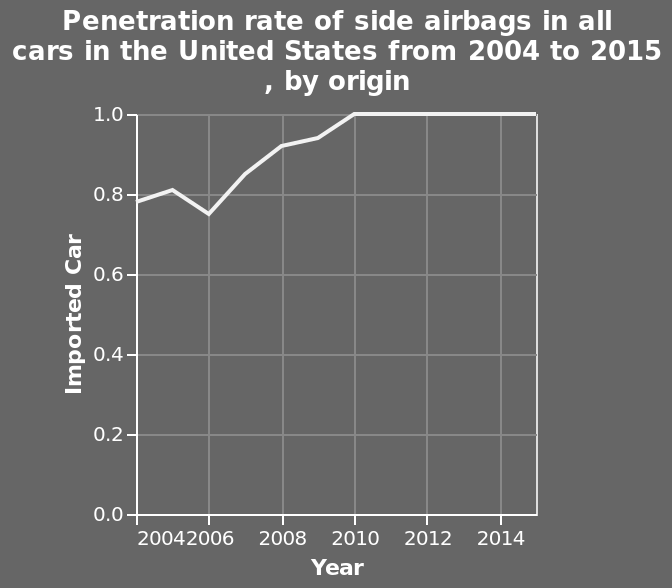<image>
How would you describe the rate from 2006 to 2010? The rate steadily inclined from 2006 until it peaked in 2010. please summary the statistics and relations of the chart There was a drop in 2006. After 2006 the rate steadily inclined until it peaked in 2010 and has since remained steady. What was the trend in the rate after 2006? The rate steadily inclined after 2006. 